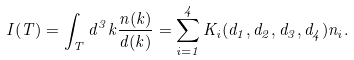<formula> <loc_0><loc_0><loc_500><loc_500>I ( T ) = \int _ { T } d ^ { 3 } k \frac { n ( { k } ) } { d ( { k } ) } = \sum _ { i = 1 } ^ { 4 } K _ { i } ( d _ { 1 } , d _ { 2 } , d _ { 3 } , d _ { 4 } ) n _ { i } .</formula> 